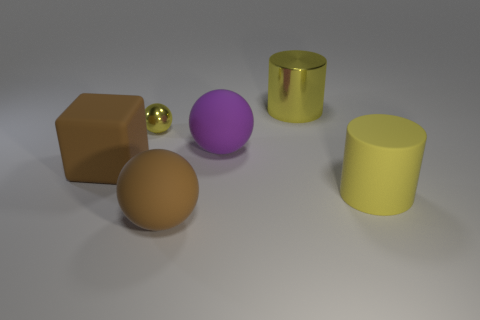Add 1 tiny yellow shiny spheres. How many objects exist? 7 Subtract all cylinders. How many objects are left? 4 Add 3 large matte balls. How many large matte balls are left? 5 Add 5 cubes. How many cubes exist? 6 Subtract 1 brown spheres. How many objects are left? 5 Subtract all tiny metallic things. Subtract all large purple matte blocks. How many objects are left? 5 